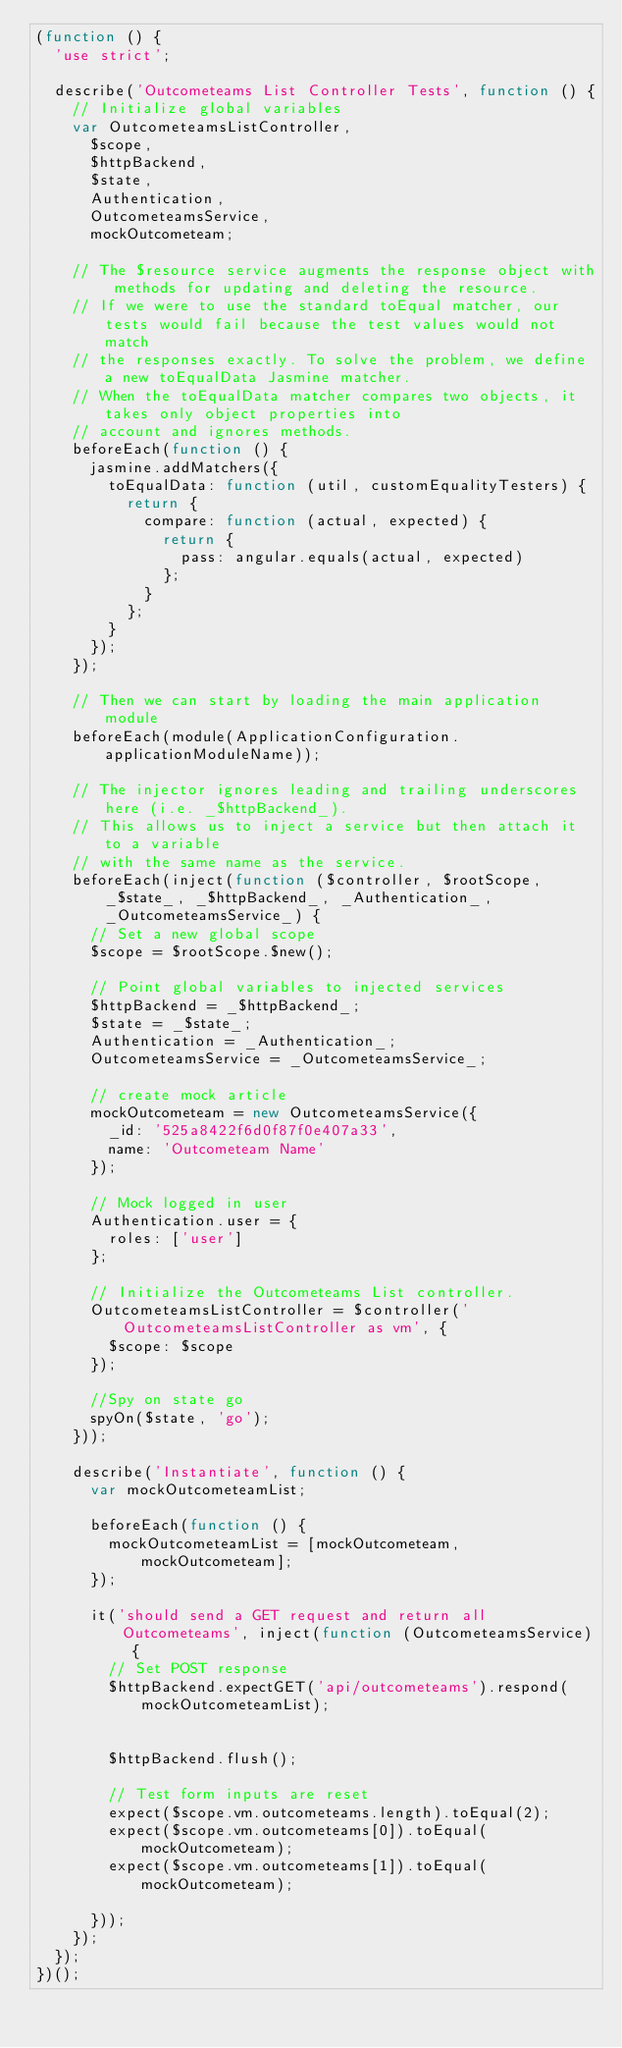<code> <loc_0><loc_0><loc_500><loc_500><_JavaScript_>(function () {
  'use strict';

  describe('Outcometeams List Controller Tests', function () {
    // Initialize global variables
    var OutcometeamsListController,
      $scope,
      $httpBackend,
      $state,
      Authentication,
      OutcometeamsService,
      mockOutcometeam;

    // The $resource service augments the response object with methods for updating and deleting the resource.
    // If we were to use the standard toEqual matcher, our tests would fail because the test values would not match
    // the responses exactly. To solve the problem, we define a new toEqualData Jasmine matcher.
    // When the toEqualData matcher compares two objects, it takes only object properties into
    // account and ignores methods.
    beforeEach(function () {
      jasmine.addMatchers({
        toEqualData: function (util, customEqualityTesters) {
          return {
            compare: function (actual, expected) {
              return {
                pass: angular.equals(actual, expected)
              };
            }
          };
        }
      });
    });

    // Then we can start by loading the main application module
    beforeEach(module(ApplicationConfiguration.applicationModuleName));

    // The injector ignores leading and trailing underscores here (i.e. _$httpBackend_).
    // This allows us to inject a service but then attach it to a variable
    // with the same name as the service.
    beforeEach(inject(function ($controller, $rootScope, _$state_, _$httpBackend_, _Authentication_, _OutcometeamsService_) {
      // Set a new global scope
      $scope = $rootScope.$new();

      // Point global variables to injected services
      $httpBackend = _$httpBackend_;
      $state = _$state_;
      Authentication = _Authentication_;
      OutcometeamsService = _OutcometeamsService_;

      // create mock article
      mockOutcometeam = new OutcometeamsService({
        _id: '525a8422f6d0f87f0e407a33',
        name: 'Outcometeam Name'
      });

      // Mock logged in user
      Authentication.user = {
        roles: ['user']
      };

      // Initialize the Outcometeams List controller.
      OutcometeamsListController = $controller('OutcometeamsListController as vm', {
        $scope: $scope
      });

      //Spy on state go
      spyOn($state, 'go');
    }));

    describe('Instantiate', function () {
      var mockOutcometeamList;

      beforeEach(function () {
        mockOutcometeamList = [mockOutcometeam, mockOutcometeam];
      });

      it('should send a GET request and return all Outcometeams', inject(function (OutcometeamsService) {
        // Set POST response
        $httpBackend.expectGET('api/outcometeams').respond(mockOutcometeamList);


        $httpBackend.flush();

        // Test form inputs are reset
        expect($scope.vm.outcometeams.length).toEqual(2);
        expect($scope.vm.outcometeams[0]).toEqual(mockOutcometeam);
        expect($scope.vm.outcometeams[1]).toEqual(mockOutcometeam);

      }));
    });
  });
})();
</code> 